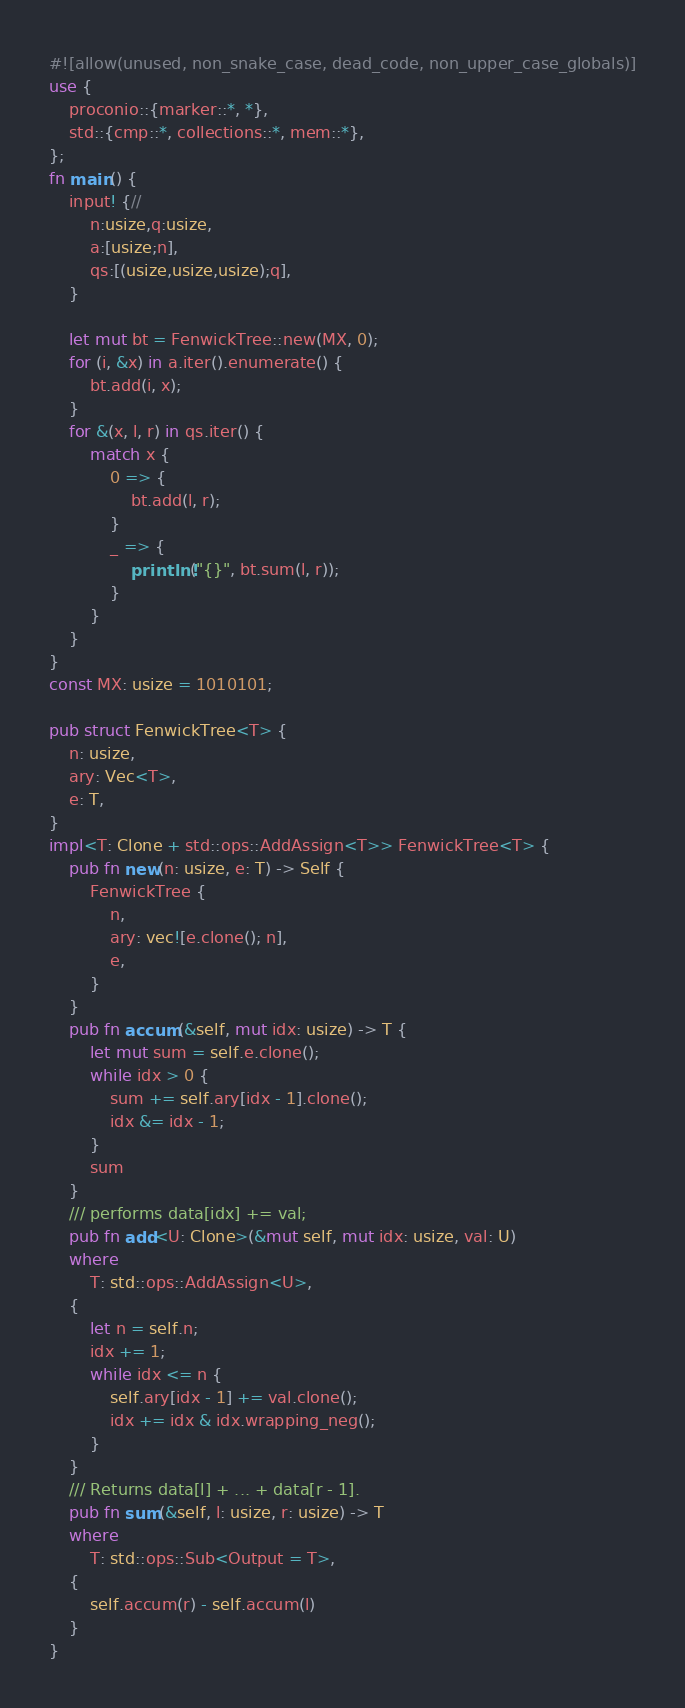Convert code to text. <code><loc_0><loc_0><loc_500><loc_500><_Rust_>#![allow(unused, non_snake_case, dead_code, non_upper_case_globals)]
use {
    proconio::{marker::*, *},
    std::{cmp::*, collections::*, mem::*},
};
fn main() {
    input! {//
        n:usize,q:usize,
        a:[usize;n],
        qs:[(usize,usize,usize);q],
    }

    let mut bt = FenwickTree::new(MX, 0);
    for (i, &x) in a.iter().enumerate() {
        bt.add(i, x);
    }
    for &(x, l, r) in qs.iter() {
        match x {
            0 => {
                bt.add(l, r);
            }
            _ => {
                println!("{}", bt.sum(l, r));
            }
        }
    }
}
const MX: usize = 1010101;

pub struct FenwickTree<T> {
    n: usize,
    ary: Vec<T>,
    e: T,
}
impl<T: Clone + std::ops::AddAssign<T>> FenwickTree<T> {
    pub fn new(n: usize, e: T) -> Self {
        FenwickTree {
            n,
            ary: vec![e.clone(); n],
            e,
        }
    }
    pub fn accum(&self, mut idx: usize) -> T {
        let mut sum = self.e.clone();
        while idx > 0 {
            sum += self.ary[idx - 1].clone();
            idx &= idx - 1;
        }
        sum
    }
    /// performs data[idx] += val;
    pub fn add<U: Clone>(&mut self, mut idx: usize, val: U)
    where
        T: std::ops::AddAssign<U>,
    {
        let n = self.n;
        idx += 1;
        while idx <= n {
            self.ary[idx - 1] += val.clone();
            idx += idx & idx.wrapping_neg();
        }
    }
    /// Returns data[l] + ... + data[r - 1].
    pub fn sum(&self, l: usize, r: usize) -> T
    where
        T: std::ops::Sub<Output = T>,
    {
        self.accum(r) - self.accum(l)
    }
}
</code> 